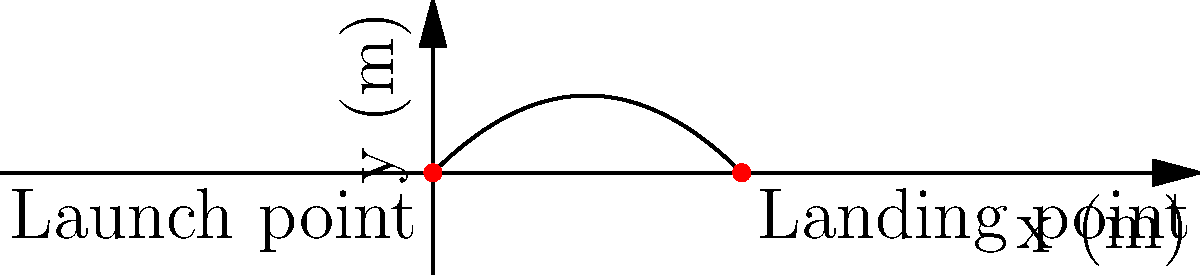A robotic catapult launches a projectile with an initial velocity of 50 m/s at an angle of 45° above the horizontal. Neglecting air resistance, calculate the maximum height reached by the projectile. How does this relate to the design parameters of the robotic catapult for optimal performance in various research scenarios? To solve this problem, we'll follow these steps:

1) The vertical component of the initial velocity is:
   $v_{0y} = v_0 \sin \theta = 50 \cdot \sin 45° = 50 \cdot \frac{\sqrt{2}}{2} \approx 35.36$ m/s

2) The time to reach maximum height is when the vertical velocity becomes zero:
   $t_{max} = \frac{v_{0y}}{g} = \frac{35.36}{9.8} \approx 3.61$ s

3) The maximum height can be calculated using the equation:
   $h_{max} = v_{0y}t - \frac{1}{2}gt^2$

   Substituting $t = \frac{t_{max}}{2}$ (as the time to reach max height is half the total time of flight):
   
   $h_{max} = v_{0y}(\frac{t_{max}}{2}) - \frac{1}{2}g(\frac{t_{max}}{2})^2$

4) Simplifying:
   $h_{max} = \frac{v_{0y}^2}{2g} = \frac{(50 \sin 45°)^2}{2(9.8)} = \frac{(35.36)^2}{19.6} \approx 63.75$ m

This result is crucial for designing robotic catapults in research scenarios:

1. It helps determine the required launch velocity for target heights.
2. It allows researchers to adjust the launch angle for different trajectory shapes.
3. It enables the calculation of impact velocity and energy for material testing.
4. It aids in designing safety measures and determining appropriate testing areas.
5. It can be used to calibrate sensors and vision systems for tracking projectiles.

Understanding these relationships allows for precise control and optimization of the robotic catapult for various research applications.
Answer: 63.75 meters 